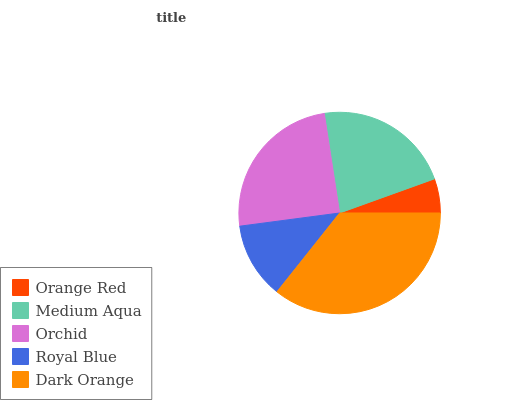Is Orange Red the minimum?
Answer yes or no. Yes. Is Dark Orange the maximum?
Answer yes or no. Yes. Is Medium Aqua the minimum?
Answer yes or no. No. Is Medium Aqua the maximum?
Answer yes or no. No. Is Medium Aqua greater than Orange Red?
Answer yes or no. Yes. Is Orange Red less than Medium Aqua?
Answer yes or no. Yes. Is Orange Red greater than Medium Aqua?
Answer yes or no. No. Is Medium Aqua less than Orange Red?
Answer yes or no. No. Is Medium Aqua the high median?
Answer yes or no. Yes. Is Medium Aqua the low median?
Answer yes or no. Yes. Is Dark Orange the high median?
Answer yes or no. No. Is Dark Orange the low median?
Answer yes or no. No. 